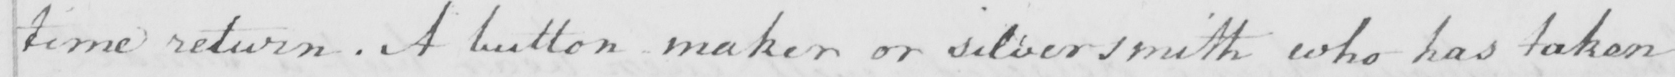What text is written in this handwritten line? time return . A button maker or silversmith who has taken 